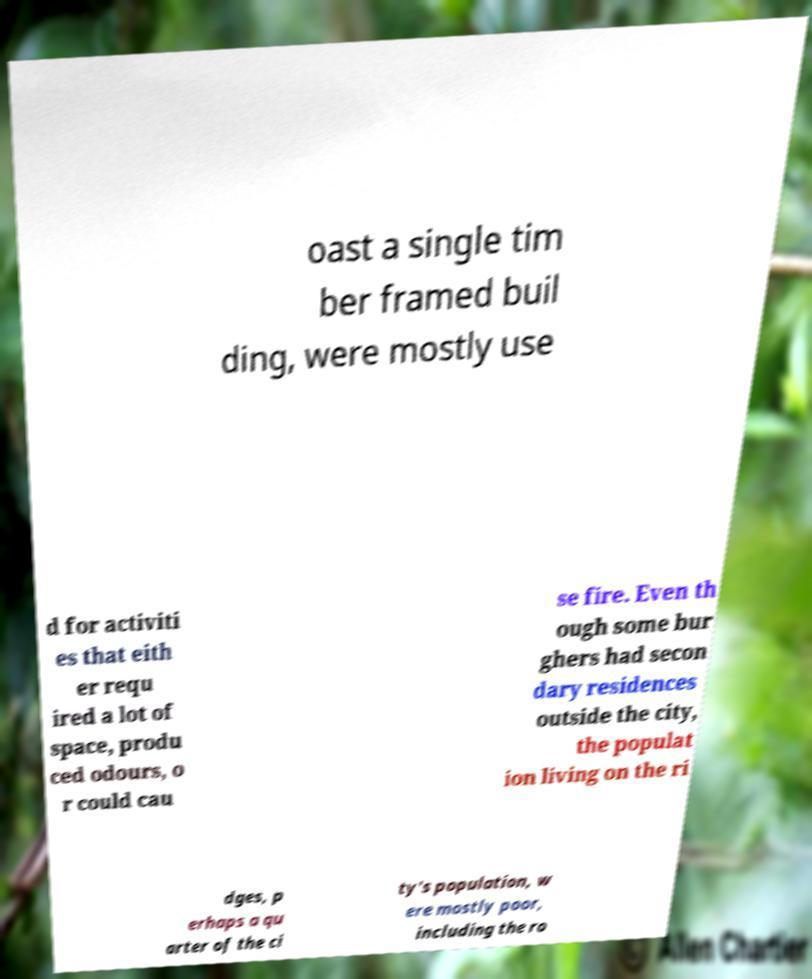Please identify and transcribe the text found in this image. oast a single tim ber framed buil ding, were mostly use d for activiti es that eith er requ ired a lot of space, produ ced odours, o r could cau se fire. Even th ough some bur ghers had secon dary residences outside the city, the populat ion living on the ri dges, p erhaps a qu arter of the ci ty's population, w ere mostly poor, including the ro 